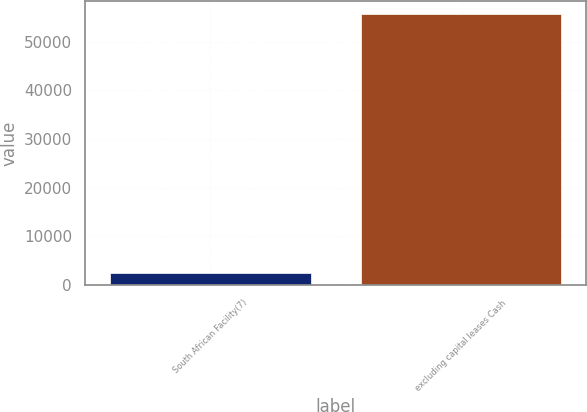<chart> <loc_0><loc_0><loc_500><loc_500><bar_chart><fcel>South African Facility(7)<fcel>excluding capital leases Cash<nl><fcel>2461<fcel>55630<nl></chart> 